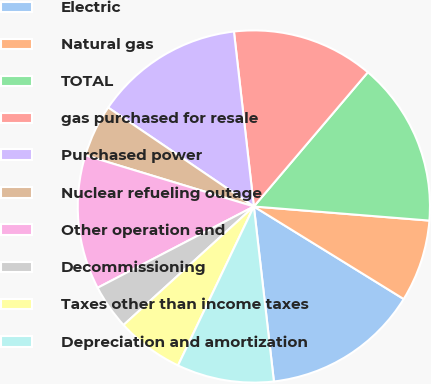Convert chart. <chart><loc_0><loc_0><loc_500><loc_500><pie_chart><fcel>Electric<fcel>Natural gas<fcel>TOTAL<fcel>gas purchased for resale<fcel>Purchased power<fcel>Nuclear refueling outage<fcel>Other operation and<fcel>Decommissioning<fcel>Taxes other than income taxes<fcel>Depreciation and amortization<nl><fcel>14.38%<fcel>7.53%<fcel>15.07%<fcel>13.01%<fcel>13.7%<fcel>4.8%<fcel>12.33%<fcel>4.11%<fcel>6.17%<fcel>8.9%<nl></chart> 